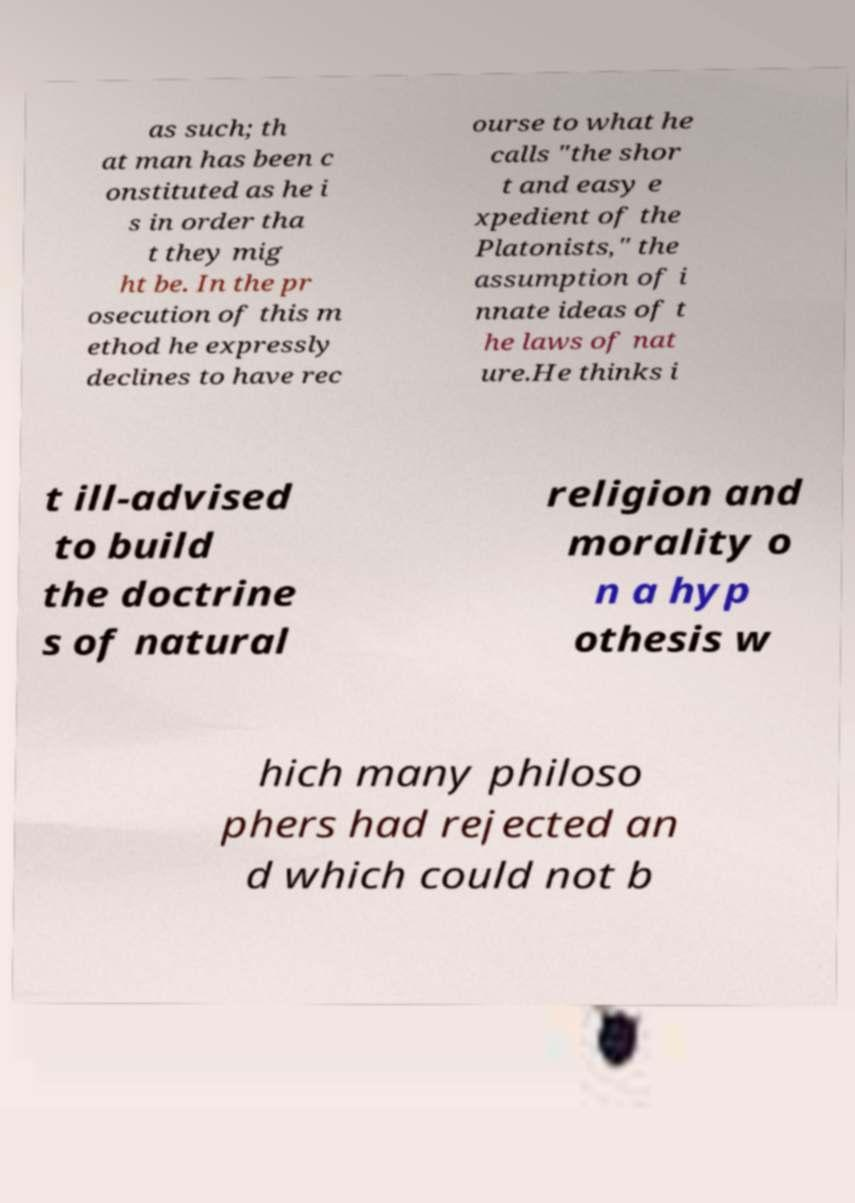I need the written content from this picture converted into text. Can you do that? as such; th at man has been c onstituted as he i s in order tha t they mig ht be. In the pr osecution of this m ethod he expressly declines to have rec ourse to what he calls "the shor t and easy e xpedient of the Platonists," the assumption of i nnate ideas of t he laws of nat ure.He thinks i t ill-advised to build the doctrine s of natural religion and morality o n a hyp othesis w hich many philoso phers had rejected an d which could not b 